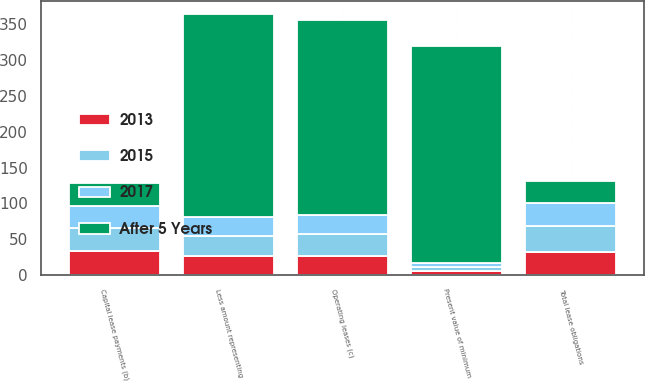Convert chart to OTSL. <chart><loc_0><loc_0><loc_500><loc_500><stacked_bar_chart><ecel><fcel>Capital lease payments (b)<fcel>Less amount representing<fcel>Present value of minimum<fcel>Operating leases (c)<fcel>Total lease obligations<nl><fcel>After 5 Years<fcel>31.5<fcel>284<fcel>304<fcel>272<fcel>31.5<nl><fcel>2015<fcel>32<fcel>27<fcel>5<fcel>31<fcel>36<nl><fcel>2017<fcel>32<fcel>27<fcel>5<fcel>27<fcel>32<nl><fcel>2013<fcel>33<fcel>27<fcel>6<fcel>26<fcel>32<nl></chart> 